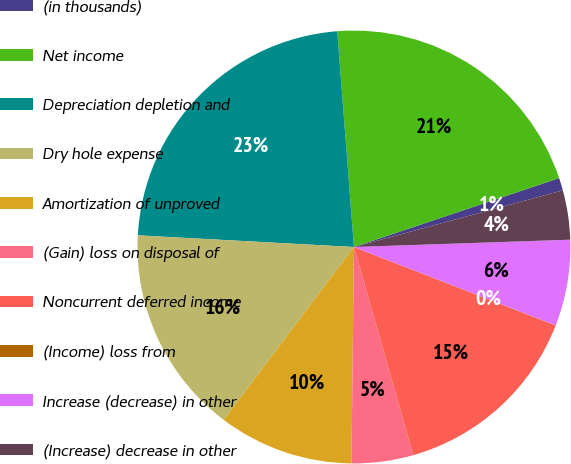Convert chart to OTSL. <chart><loc_0><loc_0><loc_500><loc_500><pie_chart><fcel>(in thousands)<fcel>Net income<fcel>Depreciation depletion and<fcel>Dry hole expense<fcel>Amortization of unproved<fcel>(Gain) loss on disposal of<fcel>Noncurrent deferred income<fcel>(Income) loss from<fcel>Increase (decrease) in other<fcel>(Increase) decrease in other<nl><fcel>0.94%<fcel>21.07%<fcel>22.91%<fcel>15.58%<fcel>10.09%<fcel>4.6%<fcel>14.67%<fcel>0.02%<fcel>6.43%<fcel>3.68%<nl></chart> 